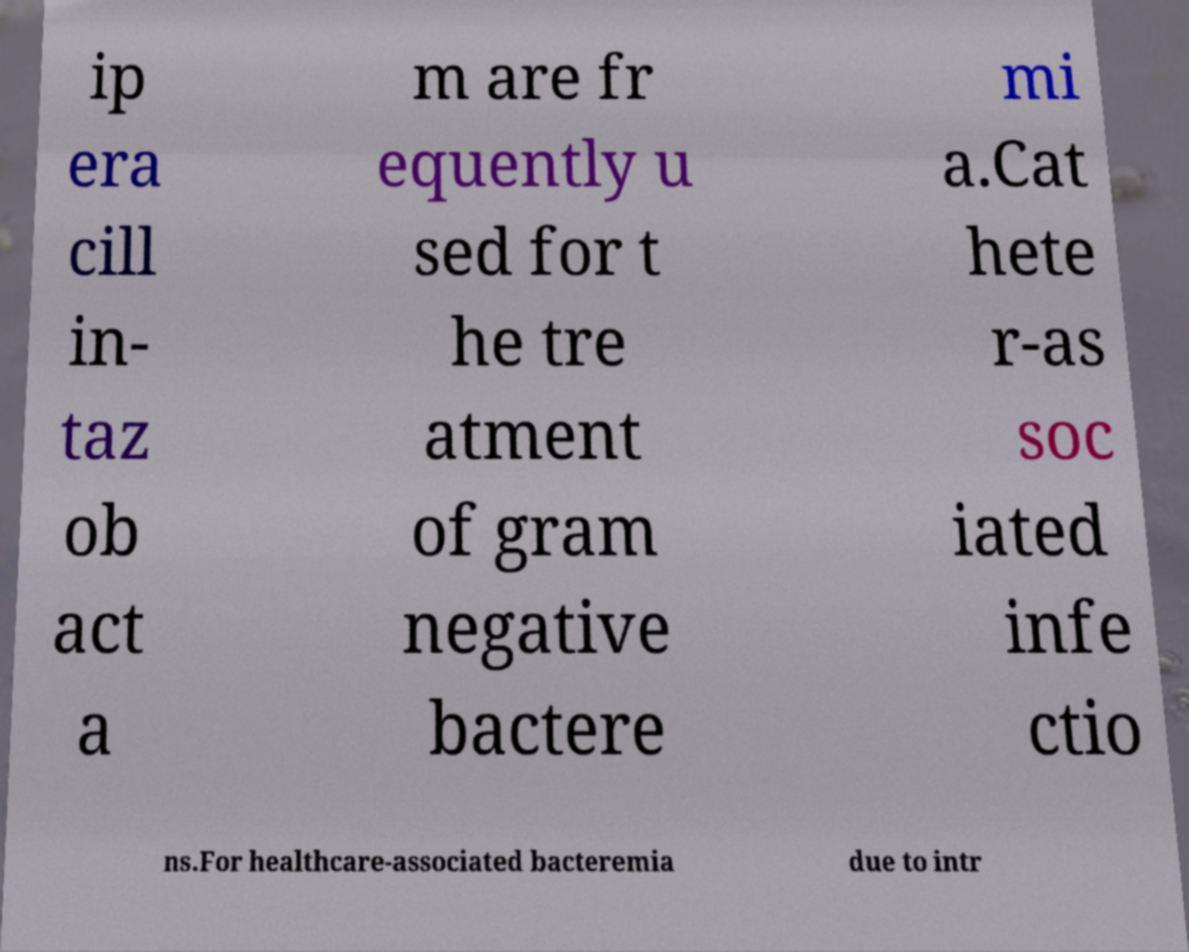What messages or text are displayed in this image? I need them in a readable, typed format. ip era cill in- taz ob act a m are fr equently u sed for t he tre atment of gram negative bactere mi a.Cat hete r-as soc iated infe ctio ns.For healthcare-associated bacteremia due to intr 